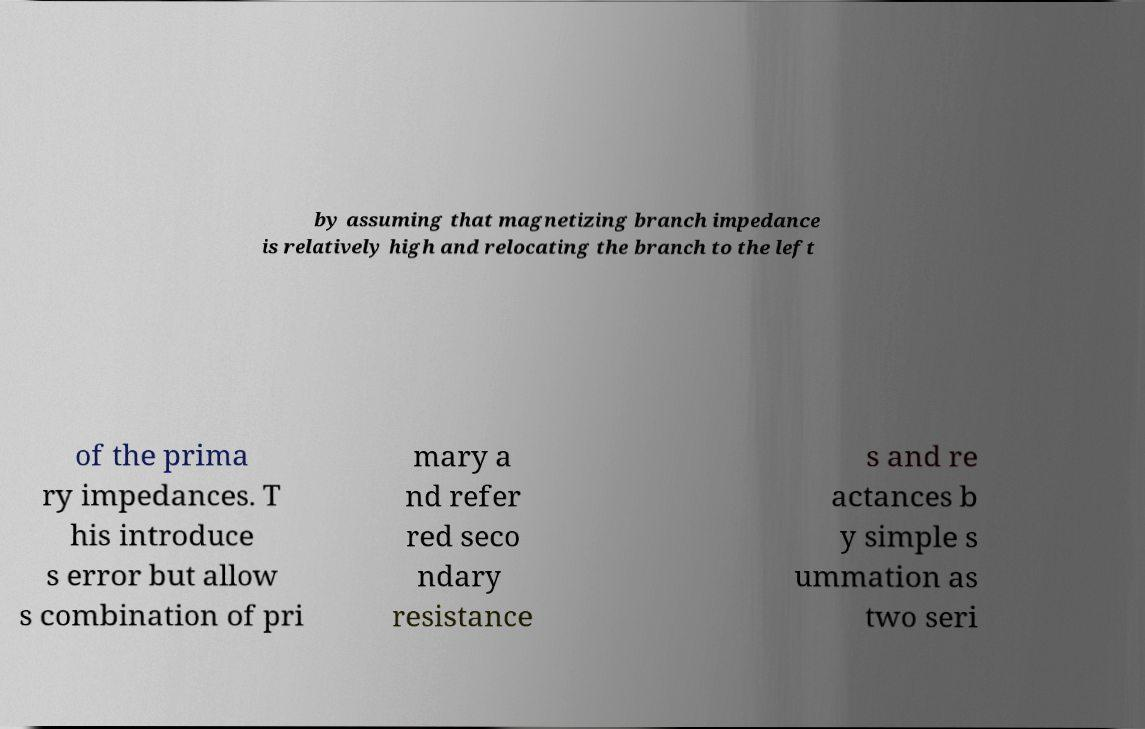Could you extract and type out the text from this image? by assuming that magnetizing branch impedance is relatively high and relocating the branch to the left of the prima ry impedances. T his introduce s error but allow s combination of pri mary a nd refer red seco ndary resistance s and re actances b y simple s ummation as two seri 